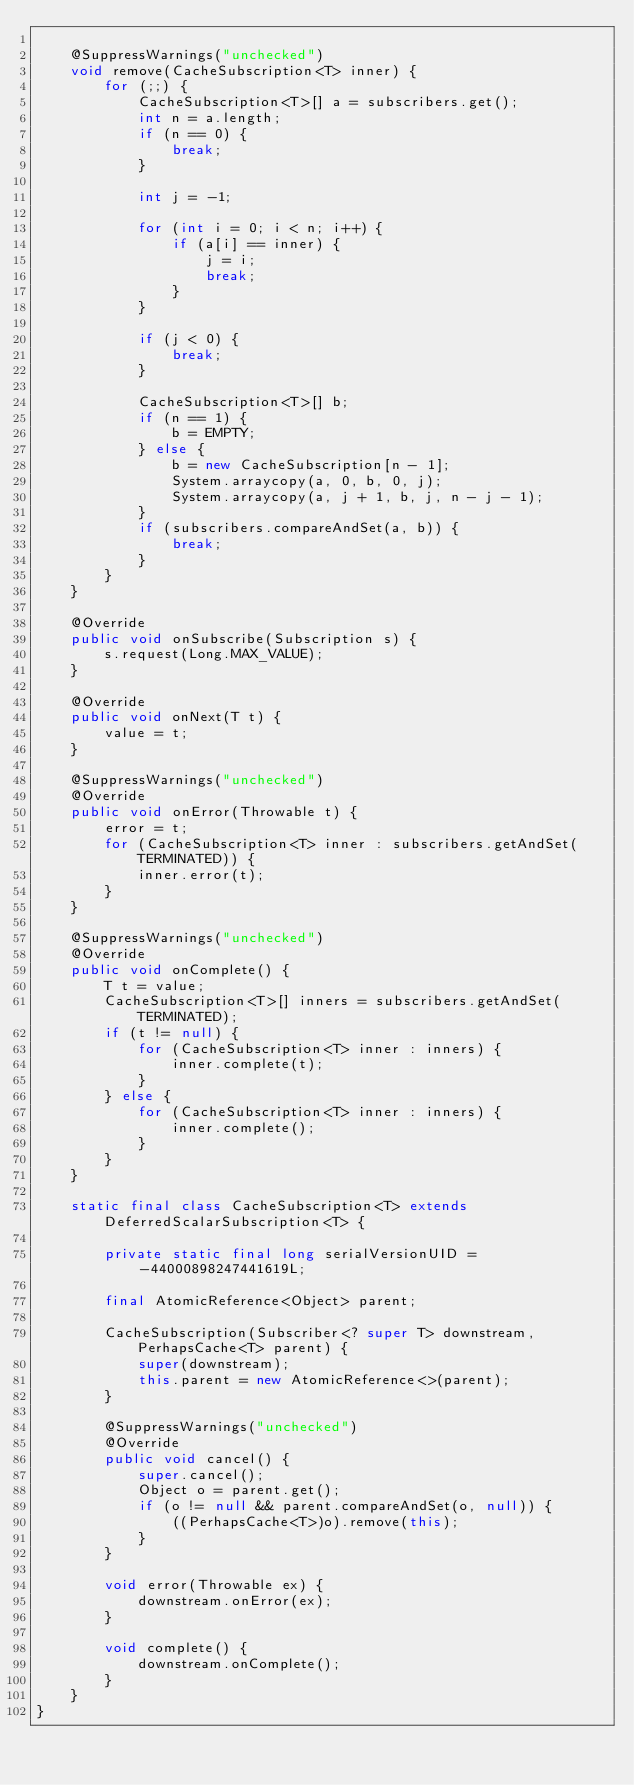Convert code to text. <code><loc_0><loc_0><loc_500><loc_500><_Java_>
    @SuppressWarnings("unchecked")
    void remove(CacheSubscription<T> inner) {
        for (;;) {
            CacheSubscription<T>[] a = subscribers.get();
            int n = a.length;
            if (n == 0) {
                break;
            }

            int j = -1;

            for (int i = 0; i < n; i++) {
                if (a[i] == inner) {
                    j = i;
                    break;
                }
            }

            if (j < 0) {
                break;
            }

            CacheSubscription<T>[] b;
            if (n == 1) {
                b = EMPTY;
            } else {
                b = new CacheSubscription[n - 1];
                System.arraycopy(a, 0, b, 0, j);
                System.arraycopy(a, j + 1, b, j, n - j - 1);
            }
            if (subscribers.compareAndSet(a, b)) {
                break;
            }
        }
    }

    @Override
    public void onSubscribe(Subscription s) {
        s.request(Long.MAX_VALUE);
    }

    @Override
    public void onNext(T t) {
        value = t;
    }

    @SuppressWarnings("unchecked")
    @Override
    public void onError(Throwable t) {
        error = t;
        for (CacheSubscription<T> inner : subscribers.getAndSet(TERMINATED)) {
            inner.error(t);
        }
    }

    @SuppressWarnings("unchecked")
    @Override
    public void onComplete() {
        T t = value;
        CacheSubscription<T>[] inners = subscribers.getAndSet(TERMINATED);
        if (t != null) {
            for (CacheSubscription<T> inner : inners) {
                inner.complete(t);
            }
        } else {
            for (CacheSubscription<T> inner : inners) {
                inner.complete();
            }
        }
    }

    static final class CacheSubscription<T> extends DeferredScalarSubscription<T> {

        private static final long serialVersionUID = -44000898247441619L;

        final AtomicReference<Object> parent;

        CacheSubscription(Subscriber<? super T> downstream, PerhapsCache<T> parent) {
            super(downstream);
            this.parent = new AtomicReference<>(parent);
        }

        @SuppressWarnings("unchecked")
        @Override
        public void cancel() {
            super.cancel();
            Object o = parent.get();
            if (o != null && parent.compareAndSet(o, null)) {
                ((PerhapsCache<T>)o).remove(this);
            }
        }

        void error(Throwable ex) {
            downstream.onError(ex);
        }

        void complete() {
            downstream.onComplete();
        }
    }
}
</code> 